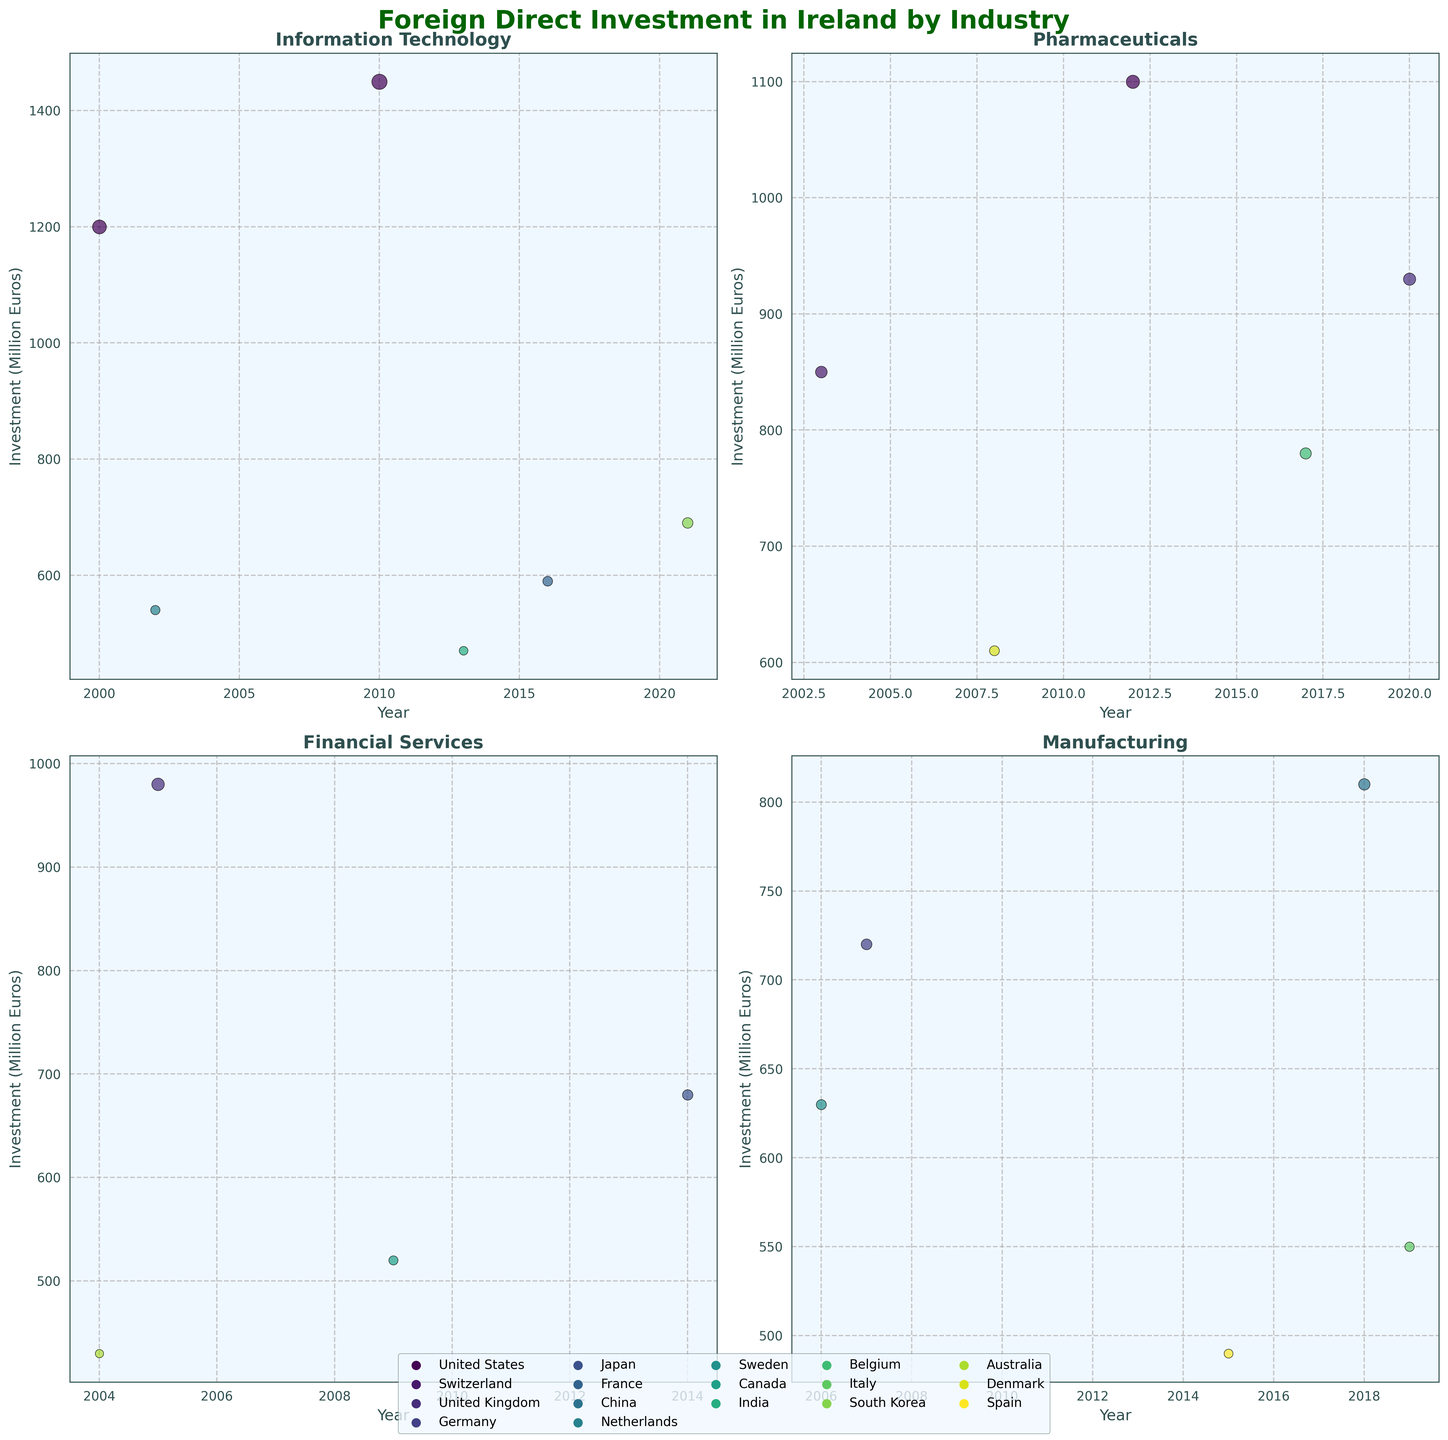What is the title of the figure? The title is prominently displayed at the top of the figure. It reads 'Foreign Direct Investment in Ireland by Industry'.
Answer: Foreign Direct Investment in Ireland by Industry Which four industries are represented in the subplot? The titles of each subplot indicate the four industries. They are Information Technology, Pharmaceuticals, Financial Services, and Manufacturing.
Answer: Information Technology, Pharmaceuticals, Financial Services, Manufacturing Which country has invested the most in Information Technology in the year 2010? In the Information Technology subplot, the scatter points representing individual years and investments show the highest investment for 2010. The color legend indicates this investment is from the United States.
Answer: United States How does the investment trend in Pharmaceuticals from 2008 to 2017 compare to that in Financial Services? Observing the Pharmaceuticals subplot, we note an increasing trend with investments in 2008, 2012, and 2017. Similarly, the Financial Services subplot shows investments in 2004, 2005, 2009, and 2014, appearing more stable over time without significant peaks.
Answer: Pharmaceuticals show an increasing trend while Financial Services remain stable Which year shows the highest total investment amount across all industries? Aggregating the scatter points from all subplots by year, 2010 in Information Technology shows the highest investment with 1450 million euros.
Answer: 2010 Compare the investment trends for Manufacturing and Financial Services. Which industry appears to have received more diverse country investments? The Manufacturing subplot shows investments from Germany, Sweden, China, Spain, and Italy, while Financial Services show investments from the UK, Australia, Canada, and Japan. Hence, Manufacturing has a more diverse set of investing countries.
Answer: Manufacturing What is the average investment in the Information Technology industry? Adding up all the investment amounts from Information Technology (1200, 1450, 540, 470, 590, 690) gives a total of 4940 million euros. Dividing this by the six data points, the average investment is approximately 823.33 million euros.
Answer: 823.33 million euros Which industry has the smallest scatter point on the graph and what year does it correspond to? The Financial Services subplot displays the smallest scatter point, which corresponds to the year 2004, representing an investment of 430 million euros.
Answer: Financial Services, 2004 How many countries have invested in the Pharmaceuticals industry? The Pharmaceuticals subplot has scatter points colored according to the countries which are United States, Switzerland, Denmark, Belgium, and the United Kingdom, making it five countries in total.
Answer: Five 